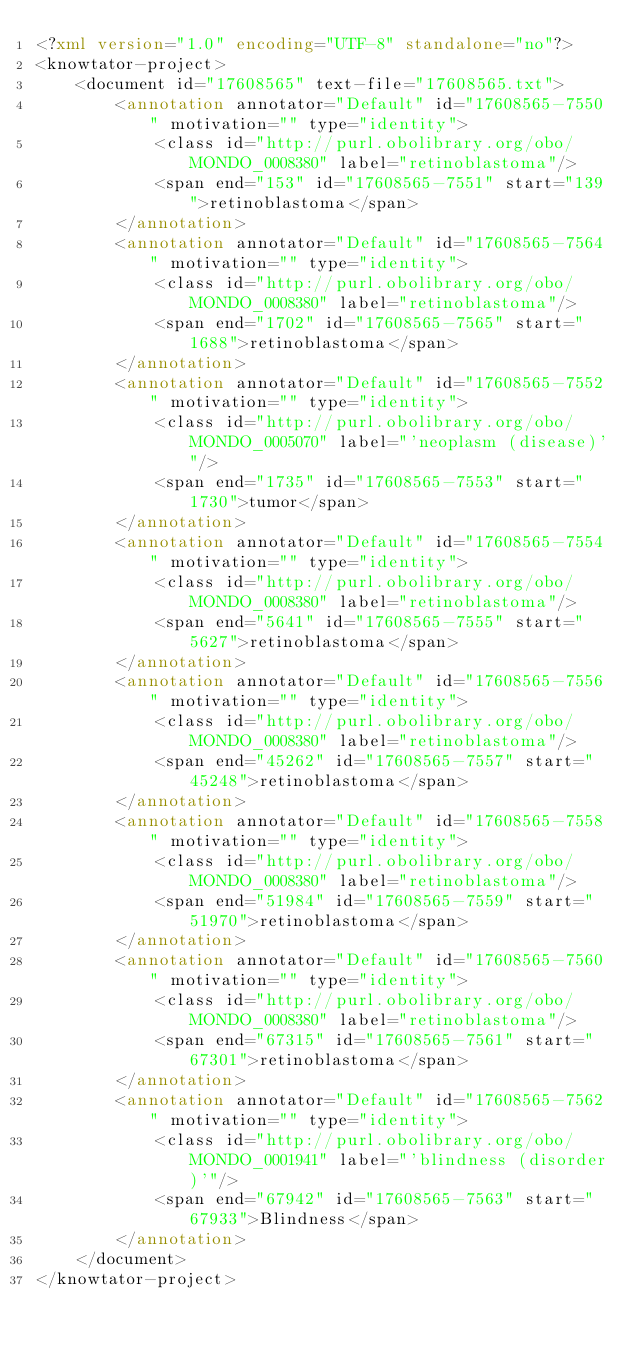<code> <loc_0><loc_0><loc_500><loc_500><_XML_><?xml version="1.0" encoding="UTF-8" standalone="no"?>
<knowtator-project>
    <document id="17608565" text-file="17608565.txt">
        <annotation annotator="Default" id="17608565-7550" motivation="" type="identity">
            <class id="http://purl.obolibrary.org/obo/MONDO_0008380" label="retinoblastoma"/>
            <span end="153" id="17608565-7551" start="139">retinoblastoma</span>
        </annotation>
        <annotation annotator="Default" id="17608565-7564" motivation="" type="identity">
            <class id="http://purl.obolibrary.org/obo/MONDO_0008380" label="retinoblastoma"/>
            <span end="1702" id="17608565-7565" start="1688">retinoblastoma</span>
        </annotation>
        <annotation annotator="Default" id="17608565-7552" motivation="" type="identity">
            <class id="http://purl.obolibrary.org/obo/MONDO_0005070" label="'neoplasm (disease)'"/>
            <span end="1735" id="17608565-7553" start="1730">tumor</span>
        </annotation>
        <annotation annotator="Default" id="17608565-7554" motivation="" type="identity">
            <class id="http://purl.obolibrary.org/obo/MONDO_0008380" label="retinoblastoma"/>
            <span end="5641" id="17608565-7555" start="5627">retinoblastoma</span>
        </annotation>
        <annotation annotator="Default" id="17608565-7556" motivation="" type="identity">
            <class id="http://purl.obolibrary.org/obo/MONDO_0008380" label="retinoblastoma"/>
            <span end="45262" id="17608565-7557" start="45248">retinoblastoma</span>
        </annotation>
        <annotation annotator="Default" id="17608565-7558" motivation="" type="identity">
            <class id="http://purl.obolibrary.org/obo/MONDO_0008380" label="retinoblastoma"/>
            <span end="51984" id="17608565-7559" start="51970">retinoblastoma</span>
        </annotation>
        <annotation annotator="Default" id="17608565-7560" motivation="" type="identity">
            <class id="http://purl.obolibrary.org/obo/MONDO_0008380" label="retinoblastoma"/>
            <span end="67315" id="17608565-7561" start="67301">retinoblastoma</span>
        </annotation>
        <annotation annotator="Default" id="17608565-7562" motivation="" type="identity">
            <class id="http://purl.obolibrary.org/obo/MONDO_0001941" label="'blindness (disorder)'"/>
            <span end="67942" id="17608565-7563" start="67933">Blindness</span>
        </annotation>
    </document>
</knowtator-project>
</code> 